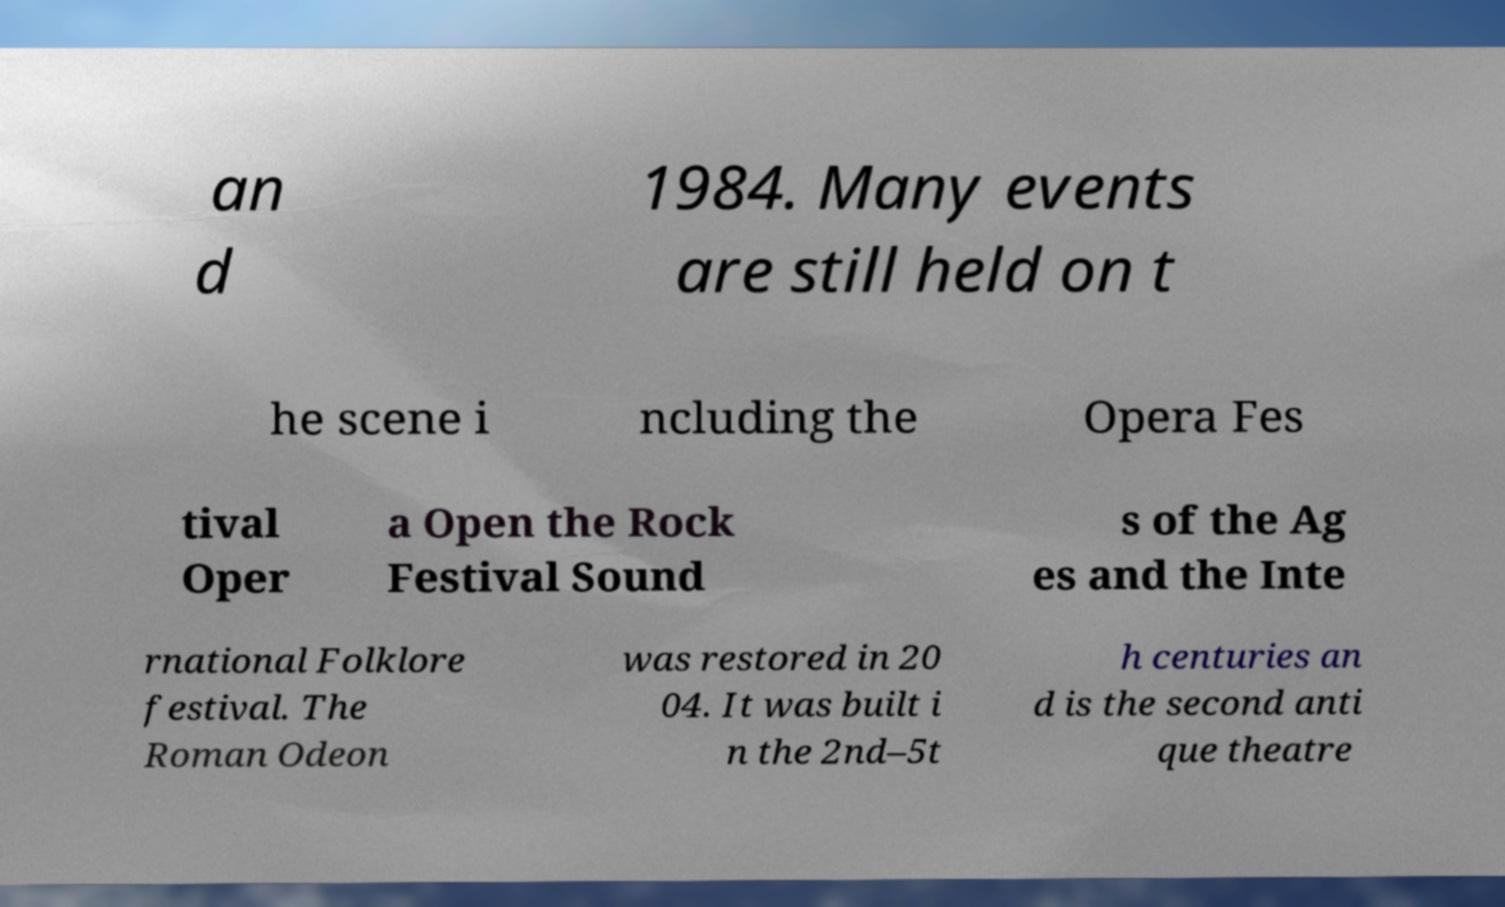For documentation purposes, I need the text within this image transcribed. Could you provide that? an d 1984. Many events are still held on t he scene i ncluding the Opera Fes tival Oper a Open the Rock Festival Sound s of the Ag es and the Inte rnational Folklore festival. The Roman Odeon was restored in 20 04. It was built i n the 2nd–5t h centuries an d is the second anti que theatre 